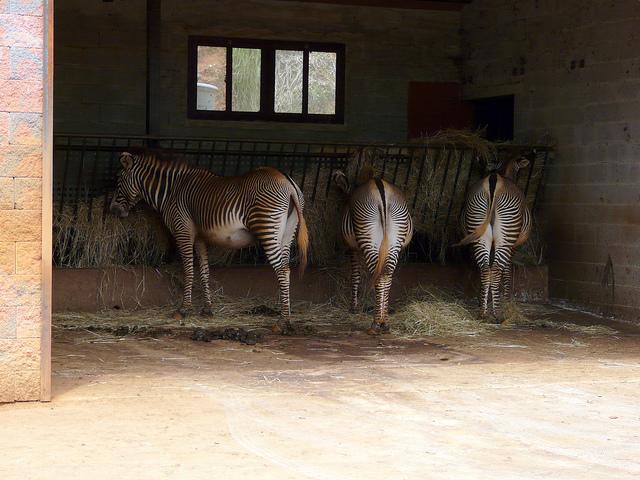What are they eating?
Concise answer only. Hay. How many animals are sitting?
Quick response, please. 0. What is the poop on the ground from?
Give a very brief answer. Zebras. Could this picture be on a calendar for animal butts?
Short answer required. Yes. 